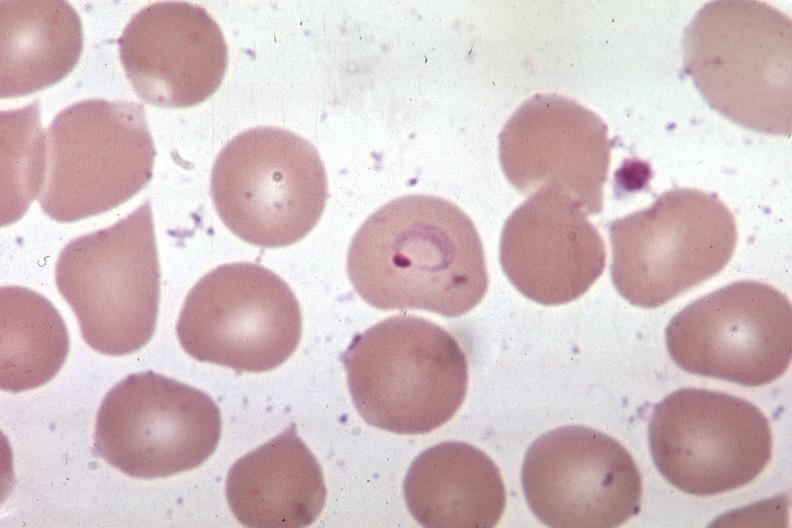s blood present?
Answer the question using a single word or phrase. Yes 